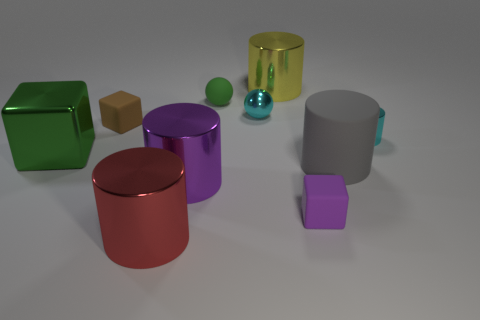There is a purple cylinder that is the same size as the green block; what material is it?
Ensure brevity in your answer.  Metal. What is the color of the small metallic cylinder?
Make the answer very short. Cyan. There is a small thing that is in front of the tiny green thing and behind the tiny brown rubber cube; what material is it?
Keep it short and to the point. Metal. There is a purple thing to the right of the metallic cylinder behind the tiny cyan metal cylinder; is there a large red shiny object behind it?
Provide a short and direct response. No. What size is the shiny cylinder that is the same color as the metallic ball?
Offer a terse response. Small. Are there any small purple rubber blocks behind the big yellow metal object?
Provide a succinct answer. No. How many other things are there of the same shape as the tiny green rubber object?
Ensure brevity in your answer.  1. There is a metallic object that is the same size as the cyan metallic ball; what color is it?
Provide a short and direct response. Cyan. Are there fewer big yellow things that are right of the large yellow metallic thing than purple blocks left of the cyan shiny sphere?
Ensure brevity in your answer.  No. There is a small rubber cube that is on the right side of the cylinder that is behind the tiny matte sphere; what number of cylinders are behind it?
Your answer should be compact. 4. 